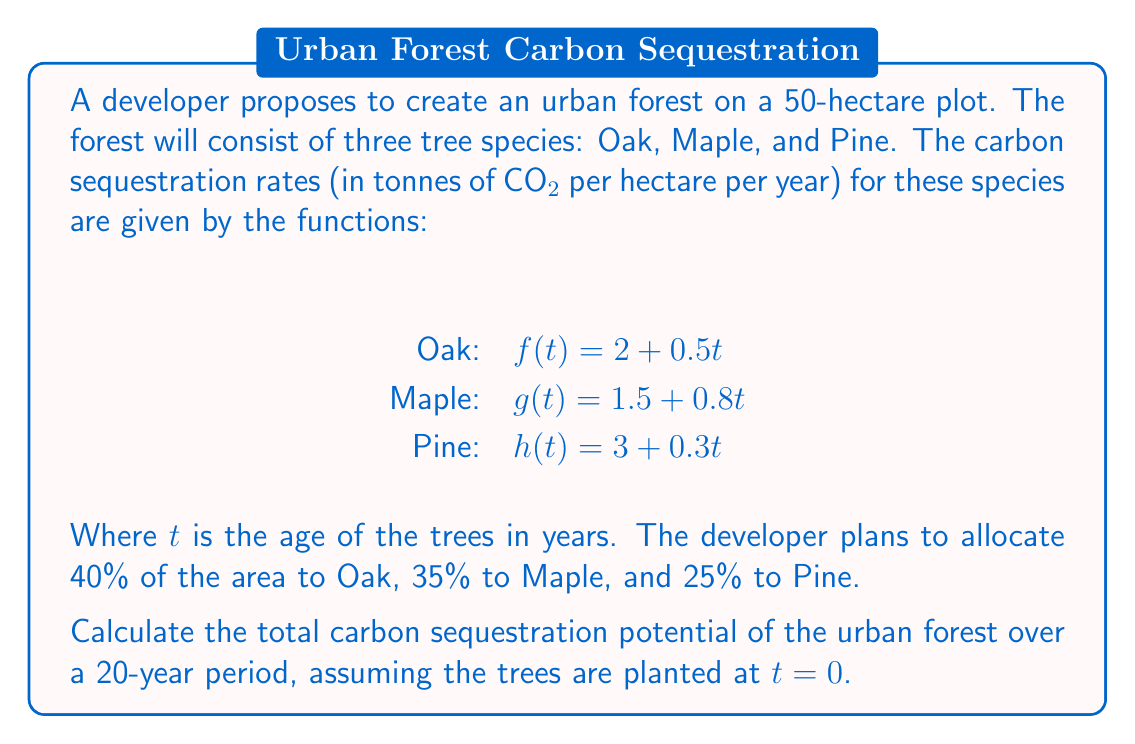Could you help me with this problem? To solve this problem, we need to follow these steps:

1) First, calculate the area allocated to each tree species:
   Oak: $0.4 \times 50 = 20$ hectares
   Maple: $0.35 \times 50 = 17.5$ hectares
   Pine: $0.25 \times 50 = 12.5$ hectares

2) For each species, we need to integrate the sequestration rate function over the 20-year period and multiply by the allocated area:

   Oak: $$\int_0^{20} (2 + 0.5t) dt \times 20$$
   Maple: $$\int_0^{20} (1.5 + 0.8t) dt \times 17.5$$
   Pine: $$\int_0^{20} (3 + 0.3t) dt \times 12.5$$

3) Let's solve each integral:

   Oak: $$\int_0^{20} (2 + 0.5t) dt = [2t + 0.25t^2]_0^{20} = (40 + 100) - (0 + 0) = 140$$
   Maple: $$\int_0^{20} (1.5 + 0.8t) dt = [1.5t + 0.4t^2]_0^{20} = (30 + 160) - (0 + 0) = 190$$
   Pine: $$\int_0^{20} (3 + 0.3t) dt = [3t + 0.15t^2]_0^{20} = (60 + 60) - (0 + 0) = 120$$

4) Now multiply each result by the allocated area:

   Oak: $140 \times 20 = 2800$ tonnes
   Maple: $190 \times 17.5 = 3325$ tonnes
   Pine: $120 \times 12.5 = 1500$ tonnes

5) Sum up the results to get the total carbon sequestration:

   Total = $2800 + 3325 + 1500 = 7625$ tonnes of CO2
Answer: 7625 tonnes of CO2 